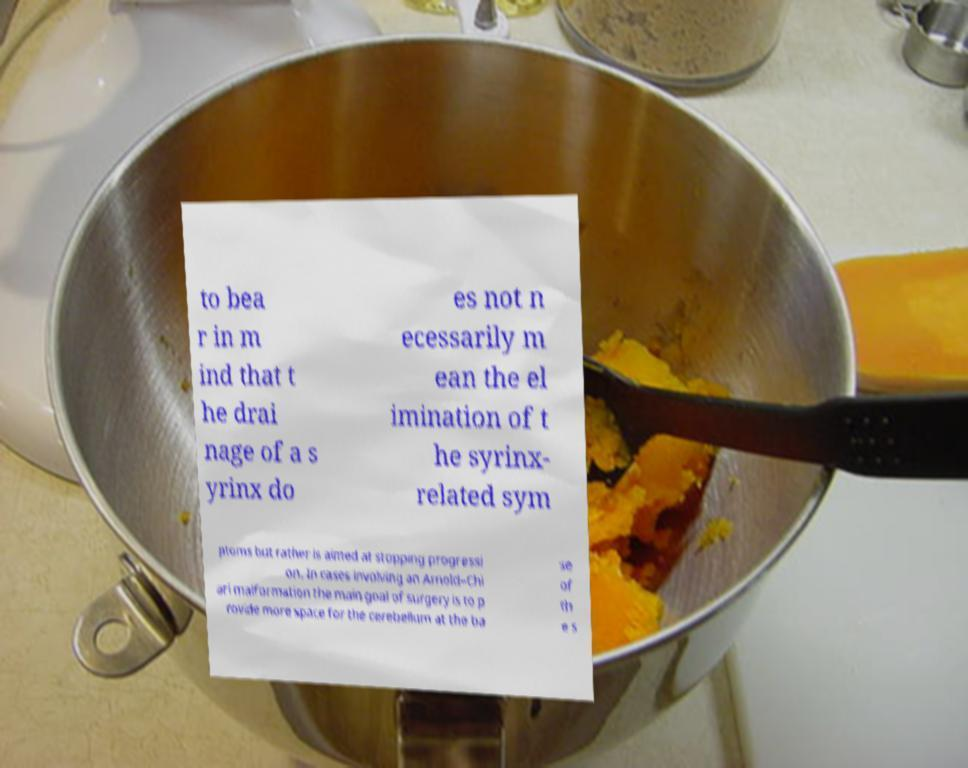What messages or text are displayed in this image? I need them in a readable, typed format. to bea r in m ind that t he drai nage of a s yrinx do es not n ecessarily m ean the el imination of t he syrinx- related sym ptoms but rather is aimed at stopping progressi on. In cases involving an Arnold–Chi ari malformation the main goal of surgery is to p rovide more space for the cerebellum at the ba se of th e s 